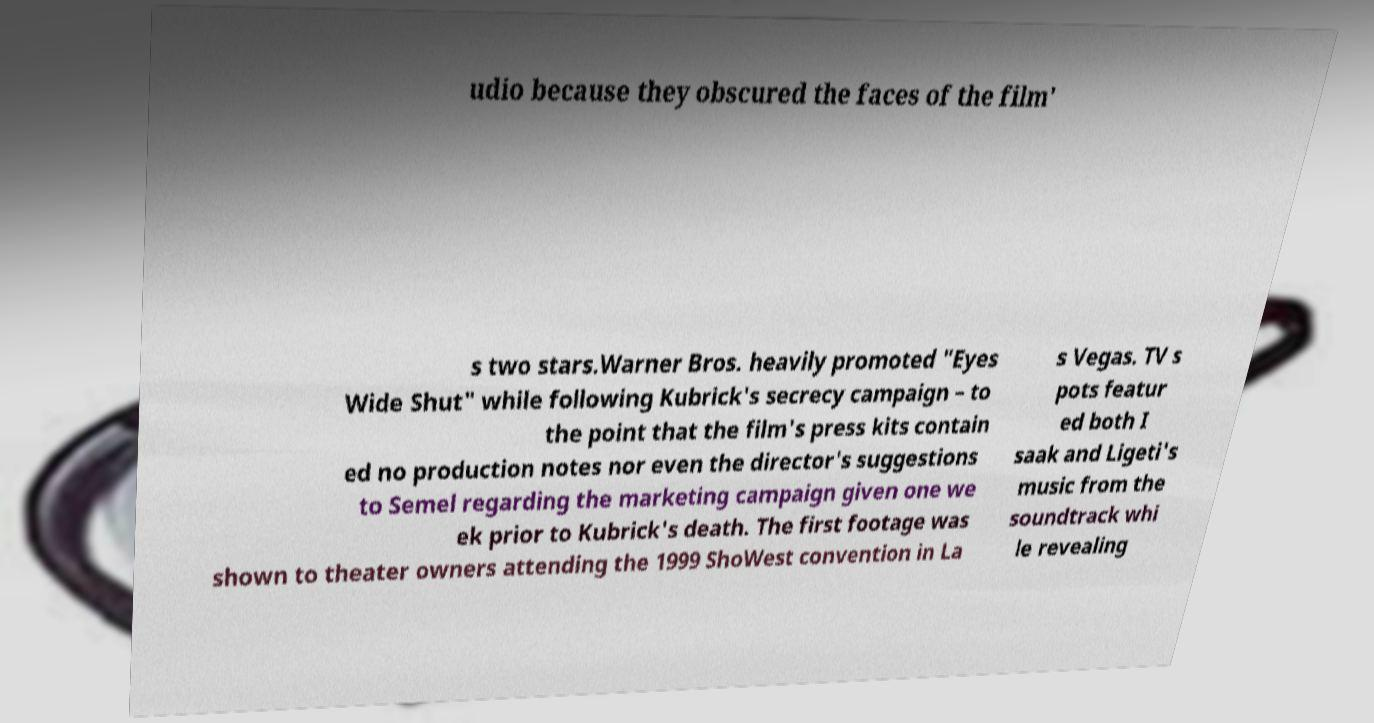For documentation purposes, I need the text within this image transcribed. Could you provide that? udio because they obscured the faces of the film' s two stars.Warner Bros. heavily promoted "Eyes Wide Shut" while following Kubrick's secrecy campaign – to the point that the film's press kits contain ed no production notes nor even the director's suggestions to Semel regarding the marketing campaign given one we ek prior to Kubrick's death. The first footage was shown to theater owners attending the 1999 ShoWest convention in La s Vegas. TV s pots featur ed both I saak and Ligeti's music from the soundtrack whi le revealing 